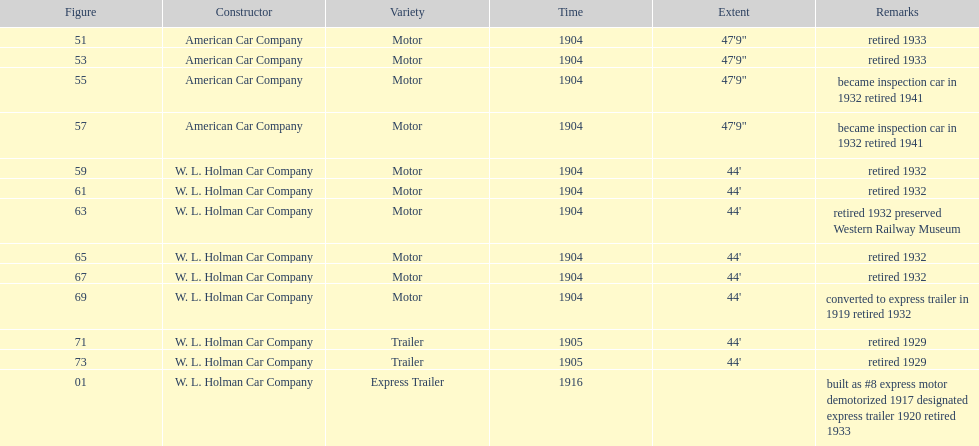How long did it take number 71 to retire? 24. 